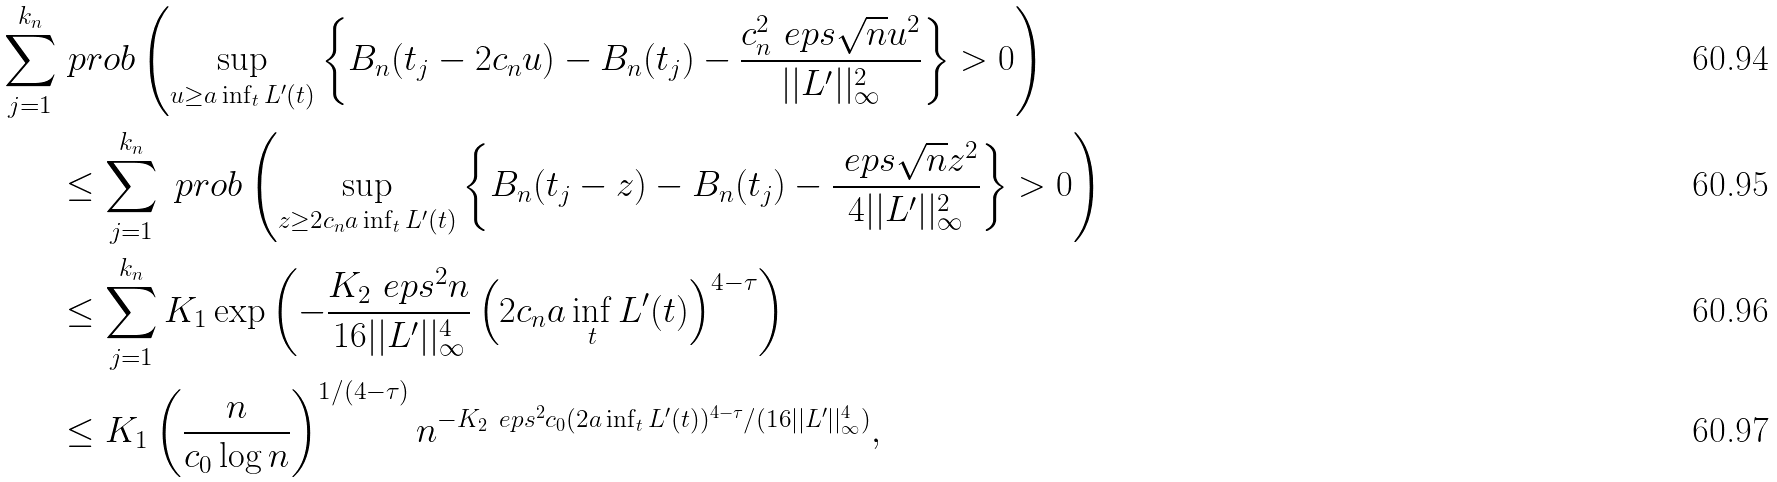Convert formula to latex. <formula><loc_0><loc_0><loc_500><loc_500>\sum _ { j = 1 } ^ { k _ { n } } & \ p r o b \left ( \sup _ { u \geq a \inf _ { t } L ^ { \prime } ( t ) } \left \{ B _ { n } ( t _ { j } - 2 c _ { n } u ) - B _ { n } ( t _ { j } ) - \frac { c _ { n } ^ { 2 } \ e p s \sqrt { n } u ^ { 2 } } { | | L ^ { \prime } | | _ { \infty } ^ { 2 } } \right \} > 0 \right ) \\ & \leq \sum _ { j = 1 } ^ { k _ { n } } \ p r o b \left ( \sup _ { z \geq 2 c _ { n } a \inf _ { t } L ^ { \prime } ( t ) } \left \{ B _ { n } ( t _ { j } - z ) - B _ { n } ( t _ { j } ) - \frac { \ e p s \sqrt { n } z ^ { 2 } } { 4 | | L ^ { \prime } | | _ { \infty } ^ { 2 } } \right \} > 0 \right ) \\ & \leq \sum _ { j = 1 } ^ { k _ { n } } K _ { 1 } \exp \left ( - \frac { K _ { 2 } \ e p s ^ { 2 } n } { 1 6 | | L ^ { \prime } | | _ { \infty } ^ { 4 } } \left ( 2 c _ { n } a \inf _ { t } L ^ { \prime } ( t ) \right ) ^ { 4 - \tau } \right ) \\ & \leq K _ { 1 } \left ( \frac { n } { c _ { 0 } \log n } \right ) ^ { 1 / ( 4 - \tau ) } n ^ { - K _ { 2 } \ e p s ^ { 2 } c _ { 0 } ( 2 a \inf _ { t } L ^ { \prime } ( t ) ) ^ { 4 - \tau } / ( 1 6 | | L ^ { \prime } | | _ { \infty } ^ { 4 } ) } ,</formula> 